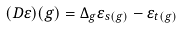<formula> <loc_0><loc_0><loc_500><loc_500>( D \varepsilon ) ( g ) = \Delta _ { g } \varepsilon _ { s ( g ) } - \varepsilon _ { t ( g ) }</formula> 